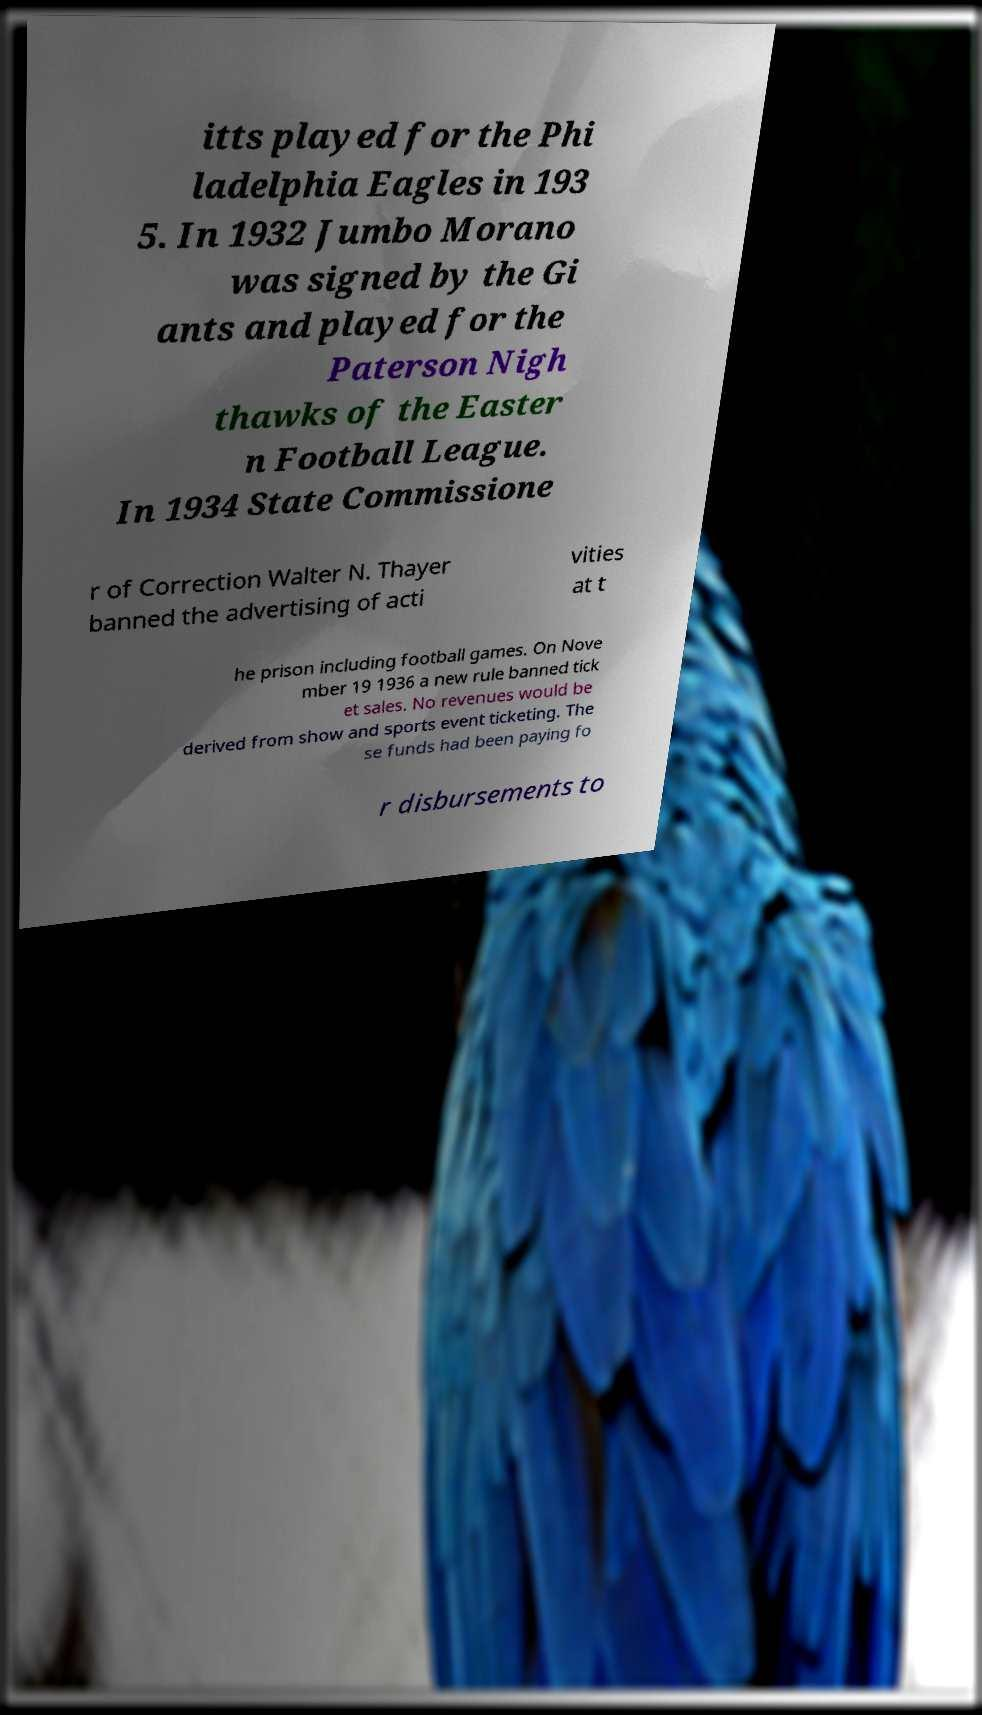There's text embedded in this image that I need extracted. Can you transcribe it verbatim? itts played for the Phi ladelphia Eagles in 193 5. In 1932 Jumbo Morano was signed by the Gi ants and played for the Paterson Nigh thawks of the Easter n Football League. In 1934 State Commissione r of Correction Walter N. Thayer banned the advertising of acti vities at t he prison including football games. On Nove mber 19 1936 a new rule banned tick et sales. No revenues would be derived from show and sports event ticketing. The se funds had been paying fo r disbursements to 